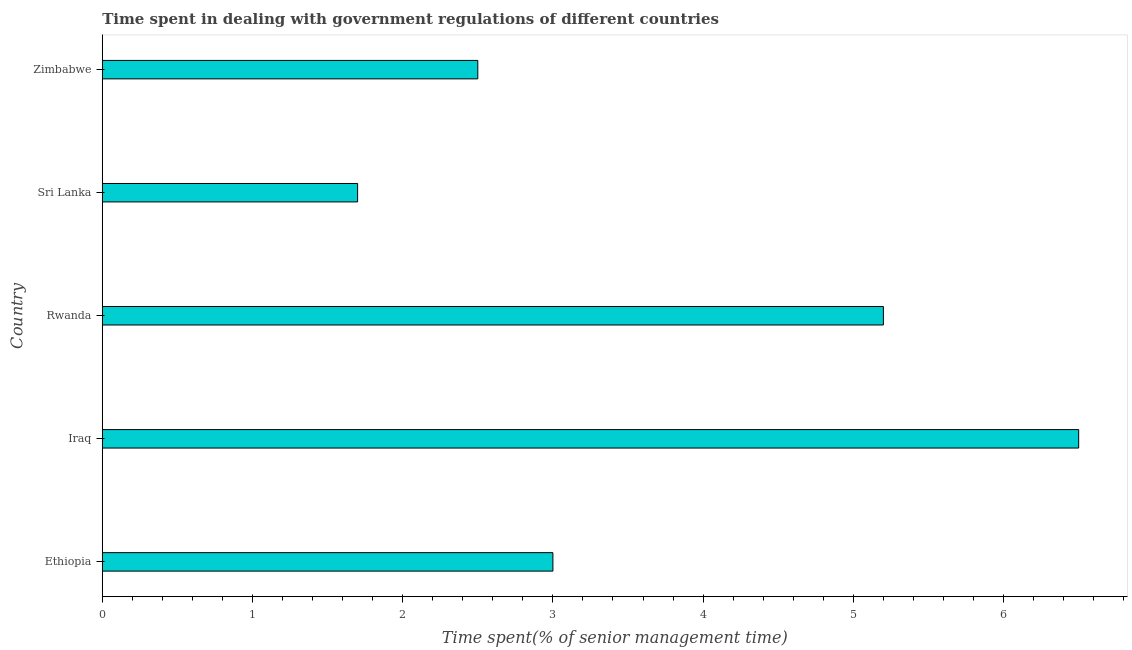Does the graph contain any zero values?
Provide a succinct answer. No. Does the graph contain grids?
Provide a succinct answer. No. What is the title of the graph?
Keep it short and to the point. Time spent in dealing with government regulations of different countries. What is the label or title of the X-axis?
Your response must be concise. Time spent(% of senior management time). What is the time spent in dealing with government regulations in Iraq?
Your answer should be compact. 6.5. In which country was the time spent in dealing with government regulations maximum?
Ensure brevity in your answer.  Iraq. In which country was the time spent in dealing with government regulations minimum?
Your answer should be very brief. Sri Lanka. What is the sum of the time spent in dealing with government regulations?
Your response must be concise. 18.9. What is the average time spent in dealing with government regulations per country?
Provide a short and direct response. 3.78. What is the ratio of the time spent in dealing with government regulations in Ethiopia to that in Zimbabwe?
Provide a short and direct response. 1.2. Is the time spent in dealing with government regulations in Sri Lanka less than that in Zimbabwe?
Your response must be concise. Yes. What is the difference between the highest and the second highest time spent in dealing with government regulations?
Keep it short and to the point. 1.3. What is the Time spent(% of senior management time) in Sri Lanka?
Keep it short and to the point. 1.7. What is the difference between the Time spent(% of senior management time) in Ethiopia and Iraq?
Offer a very short reply. -3.5. What is the difference between the Time spent(% of senior management time) in Ethiopia and Sri Lanka?
Provide a succinct answer. 1.3. What is the difference between the Time spent(% of senior management time) in Iraq and Sri Lanka?
Your response must be concise. 4.8. What is the difference between the Time spent(% of senior management time) in Rwanda and Sri Lanka?
Offer a very short reply. 3.5. What is the difference between the Time spent(% of senior management time) in Rwanda and Zimbabwe?
Your answer should be compact. 2.7. What is the ratio of the Time spent(% of senior management time) in Ethiopia to that in Iraq?
Offer a very short reply. 0.46. What is the ratio of the Time spent(% of senior management time) in Ethiopia to that in Rwanda?
Offer a terse response. 0.58. What is the ratio of the Time spent(% of senior management time) in Ethiopia to that in Sri Lanka?
Your response must be concise. 1.76. What is the ratio of the Time spent(% of senior management time) in Ethiopia to that in Zimbabwe?
Give a very brief answer. 1.2. What is the ratio of the Time spent(% of senior management time) in Iraq to that in Rwanda?
Offer a very short reply. 1.25. What is the ratio of the Time spent(% of senior management time) in Iraq to that in Sri Lanka?
Provide a succinct answer. 3.82. What is the ratio of the Time spent(% of senior management time) in Iraq to that in Zimbabwe?
Ensure brevity in your answer.  2.6. What is the ratio of the Time spent(% of senior management time) in Rwanda to that in Sri Lanka?
Your answer should be very brief. 3.06. What is the ratio of the Time spent(% of senior management time) in Rwanda to that in Zimbabwe?
Provide a succinct answer. 2.08. What is the ratio of the Time spent(% of senior management time) in Sri Lanka to that in Zimbabwe?
Give a very brief answer. 0.68. 